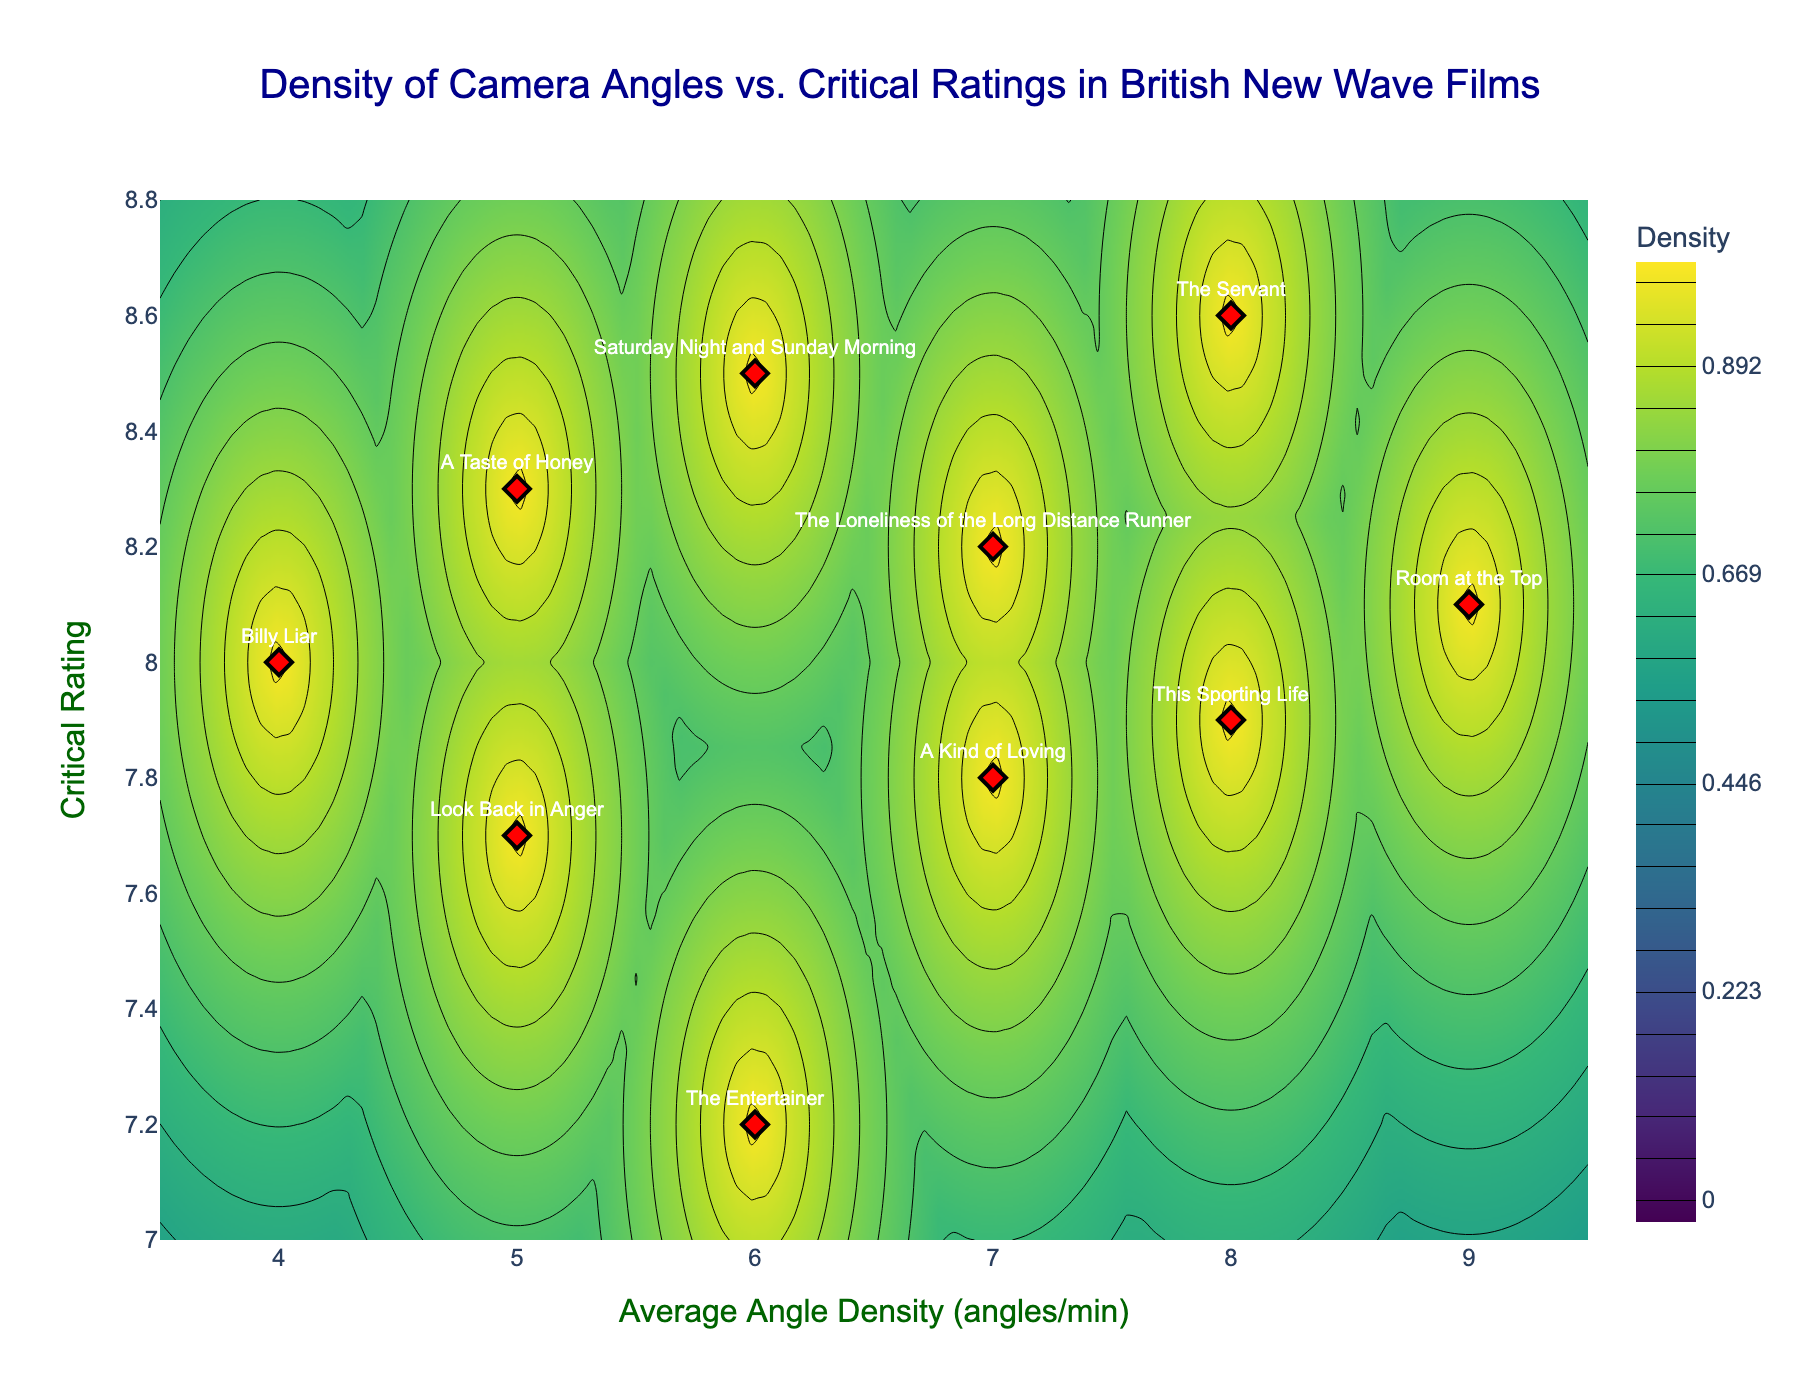What's the title of the figure? The title is located at the top center of the figure and reads "Density of Camera Angles vs. Critical Ratings in British New Wave Films".
Answer: Density of Camera Angles vs. Critical Ratings in British New Wave Films What are the labels on the X and Y axes? The label on the X-axis is "Average Angle Density (angles/min)" and the label on the Y-axis is "Critical Rating". These labels are placed along the respective axes.
Answer: Average Angle Density (angles/min) and Critical Rating How many films are plotted as data points in the figure? The figure uses scatter markers to show the films, and there are 10 data points in total, each representing a different film.
Answer: 10 Which film has the highest Average Angle Density (angles/min)? By looking at the scatter points, "Room at the Top" has the highest Average Angle Density at 9 angles per minute.
Answer: Room at the Top Which film has the lowest Critical Rating? "The Entertainer" has the lowest Critical Rating which can be identified by its position on the Y-axis at a rating of 7.2.
Answer: The Entertainer What is the critical rating of "Look Back in Anger"? The scatter point labeled "Look Back in Anger" is positioned at a Critical Rating of 7.7, which can be read directly from its vertical position on the Y-axis.
Answer: 7.7 Compare "A Taste of Honey" and "Billy Liar" in terms of Average Angle Density and Critical Rating. "A Taste of Honey" has an Average Angle Density of 5 and a Critical Rating of 8.3, whereas "Billy Liar" has a lower Average Angle Density of 4 but also a Critical Rating of 8.0. Thus, "A Taste of Honey" has a higher Critical Rating and also a higher Average Angle Density than "Billy Liar".
Answer: "A Taste of Honey" has higher values in both metrics What's the range of Average Angle Density (angles/min) in the figure? The minimum Average Angle Density is 4 (from "Billy Liar") and the maximum is 9 (from "Room at the Top"). So, the range is 9 - 4 = 5 angles per minute.
Answer: 5 What is the range of Critical Ratings in the figure? The Critical Ratings range from 7.2 (The Entertainer) to 8.6 (The Servant), giving a range of 8.6 - 7.2 = 1.4.
Answer: 1.4 Which film is closest to the contour plot's highest density region? By observing the contour plot's color gradient, "The Servant" (with an Average Angle Density of 8 and a Critical Rating of 8.6) is closest to the highest density region.
Answer: The Servant 